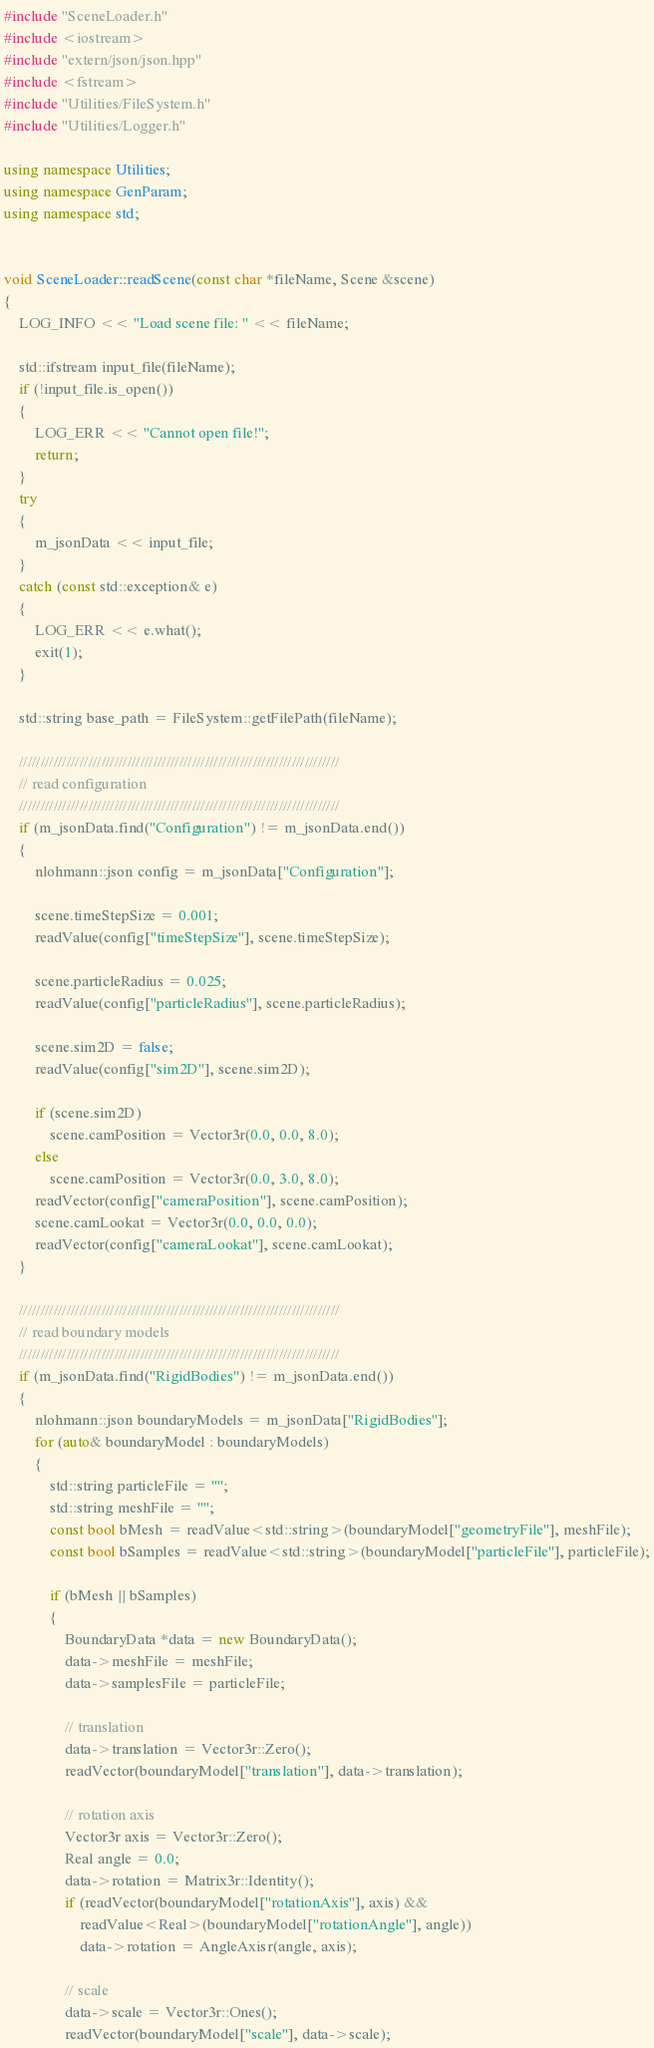Convert code to text. <code><loc_0><loc_0><loc_500><loc_500><_C++_>#include "SceneLoader.h"
#include <iostream>
#include "extern/json/json.hpp"
#include <fstream>
#include "Utilities/FileSystem.h"
#include "Utilities/Logger.h"

using namespace Utilities;
using namespace GenParam;
using namespace std;


void SceneLoader::readScene(const char *fileName, Scene &scene)
{
	LOG_INFO << "Load scene file: " << fileName;

	std::ifstream input_file(fileName);
	if (!input_file.is_open())
	{
		LOG_ERR << "Cannot open file!";
		return;
	}
	try
	{
		m_jsonData << input_file;
	}
	catch (const std::exception& e)
	{
		LOG_ERR << e.what();
		exit(1);
	}	

	std::string base_path = FileSystem::getFilePath(fileName);

	//////////////////////////////////////////////////////////////////////////
	// read configuration 
	//////////////////////////////////////////////////////////////////////////
	if (m_jsonData.find("Configuration") != m_jsonData.end())
	{
		nlohmann::json config = m_jsonData["Configuration"];

		scene.timeStepSize = 0.001;
		readValue(config["timeStepSize"], scene.timeStepSize);

		scene.particleRadius = 0.025;
		readValue(config["particleRadius"], scene.particleRadius);

		scene.sim2D = false;
		readValue(config["sim2D"], scene.sim2D);

		if (scene.sim2D)
			scene.camPosition = Vector3r(0.0, 0.0, 8.0);
		else
			scene.camPosition = Vector3r(0.0, 3.0, 8.0);
		readVector(config["cameraPosition"], scene.camPosition);
		scene.camLookat = Vector3r(0.0, 0.0, 0.0);
		readVector(config["cameraLookat"], scene.camLookat);
	}

	//////////////////////////////////////////////////////////////////////////
	// read boundary models
	//////////////////////////////////////////////////////////////////////////
	if (m_jsonData.find("RigidBodies") != m_jsonData.end())
	{
		nlohmann::json boundaryModels = m_jsonData["RigidBodies"];
		for (auto& boundaryModel : boundaryModels)
		{
			std::string particleFile = "";
			std::string meshFile = "";
			const bool bMesh = readValue<std::string>(boundaryModel["geometryFile"], meshFile);
			const bool bSamples = readValue<std::string>(boundaryModel["particleFile"], particleFile);

			if (bMesh || bSamples)
			{
				BoundaryData *data = new BoundaryData();
				data->meshFile = meshFile;
				data->samplesFile = particleFile;

				// translation
				data->translation = Vector3r::Zero();
				readVector(boundaryModel["translation"], data->translation);

				// rotation axis
				Vector3r axis = Vector3r::Zero();
				Real angle = 0.0;
				data->rotation = Matrix3r::Identity();
				if (readVector(boundaryModel["rotationAxis"], axis) &&
					readValue<Real>(boundaryModel["rotationAngle"], angle))
					data->rotation = AngleAxisr(angle, axis);

				// scale
				data->scale = Vector3r::Ones();
				readVector(boundaryModel["scale"], data->scale);
</code> 